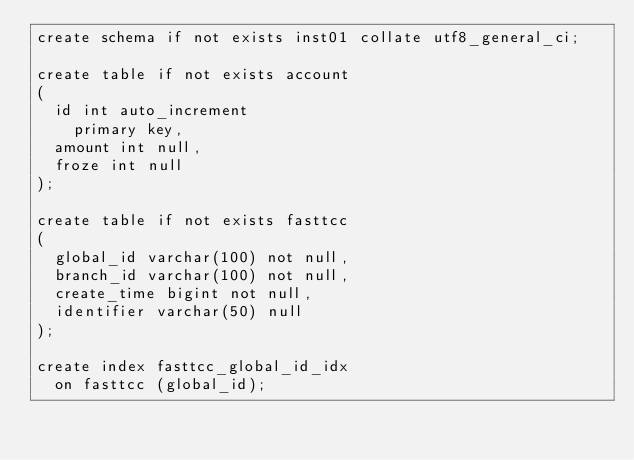Convert code to text. <code><loc_0><loc_0><loc_500><loc_500><_SQL_>create schema if not exists inst01 collate utf8_general_ci;

create table if not exists account
(
	id int auto_increment
		primary key,
	amount int null,
	froze int null
);

create table if not exists fasttcc
(
	global_id varchar(100) not null,
	branch_id varchar(100) not null,
	create_time bigint not null,
	identifier varchar(50) null
);

create index fasttcc_global_id_idx
	on fasttcc (global_id);

</code> 